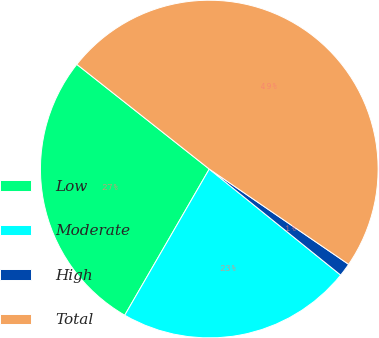<chart> <loc_0><loc_0><loc_500><loc_500><pie_chart><fcel>Low<fcel>Moderate<fcel>High<fcel>Total<nl><fcel>27.3%<fcel>22.54%<fcel>1.26%<fcel>48.9%<nl></chart> 